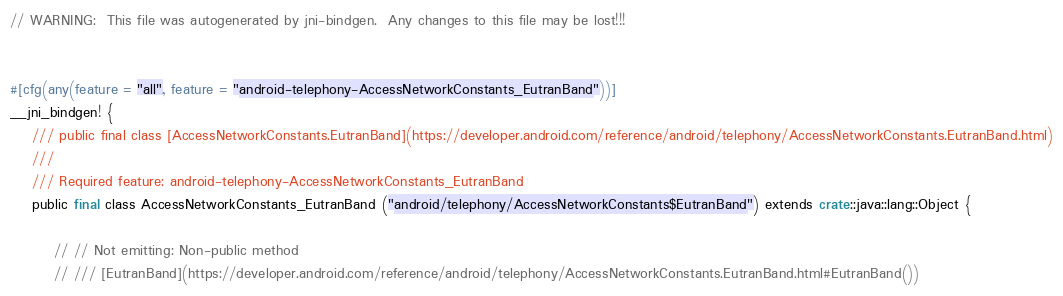Convert code to text. <code><loc_0><loc_0><loc_500><loc_500><_Rust_>// WARNING:  This file was autogenerated by jni-bindgen.  Any changes to this file may be lost!!!


#[cfg(any(feature = "all", feature = "android-telephony-AccessNetworkConstants_EutranBand"))]
__jni_bindgen! {
    /// public final class [AccessNetworkConstants.EutranBand](https://developer.android.com/reference/android/telephony/AccessNetworkConstants.EutranBand.html)
    ///
    /// Required feature: android-telephony-AccessNetworkConstants_EutranBand
    public final class AccessNetworkConstants_EutranBand ("android/telephony/AccessNetworkConstants$EutranBand") extends crate::java::lang::Object {

        // // Not emitting: Non-public method
        // /// [EutranBand](https://developer.android.com/reference/android/telephony/AccessNetworkConstants.EutranBand.html#EutranBand())</code> 